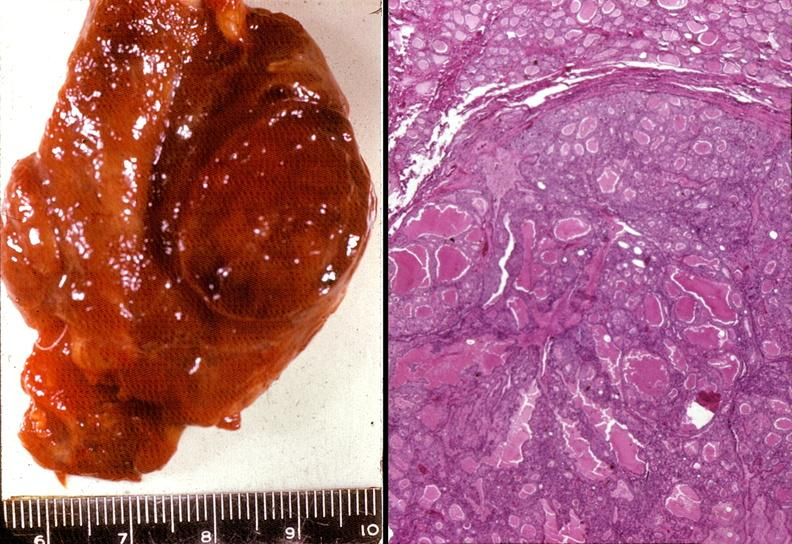s endocrine present?
Answer the question using a single word or phrase. Yes 